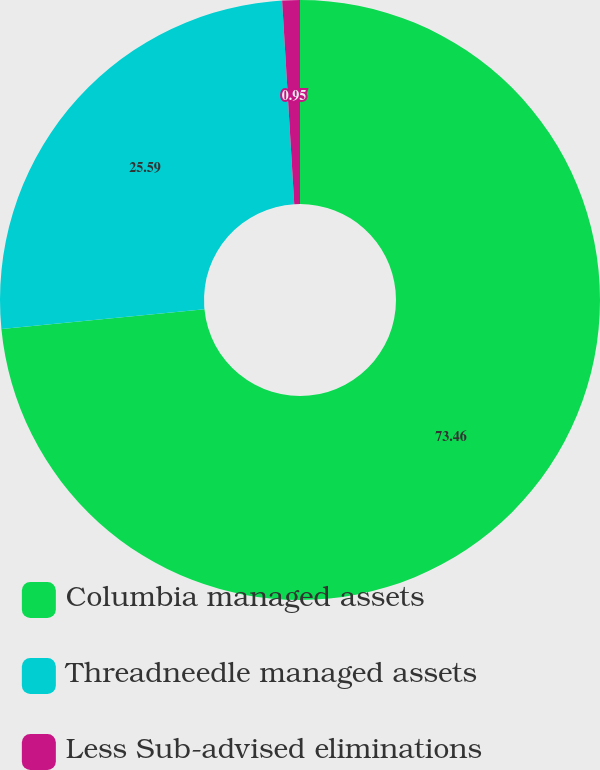Convert chart to OTSL. <chart><loc_0><loc_0><loc_500><loc_500><pie_chart><fcel>Columbia managed assets<fcel>Threadneedle managed assets<fcel>Less Sub-advised eliminations<nl><fcel>73.46%<fcel>25.59%<fcel>0.95%<nl></chart> 